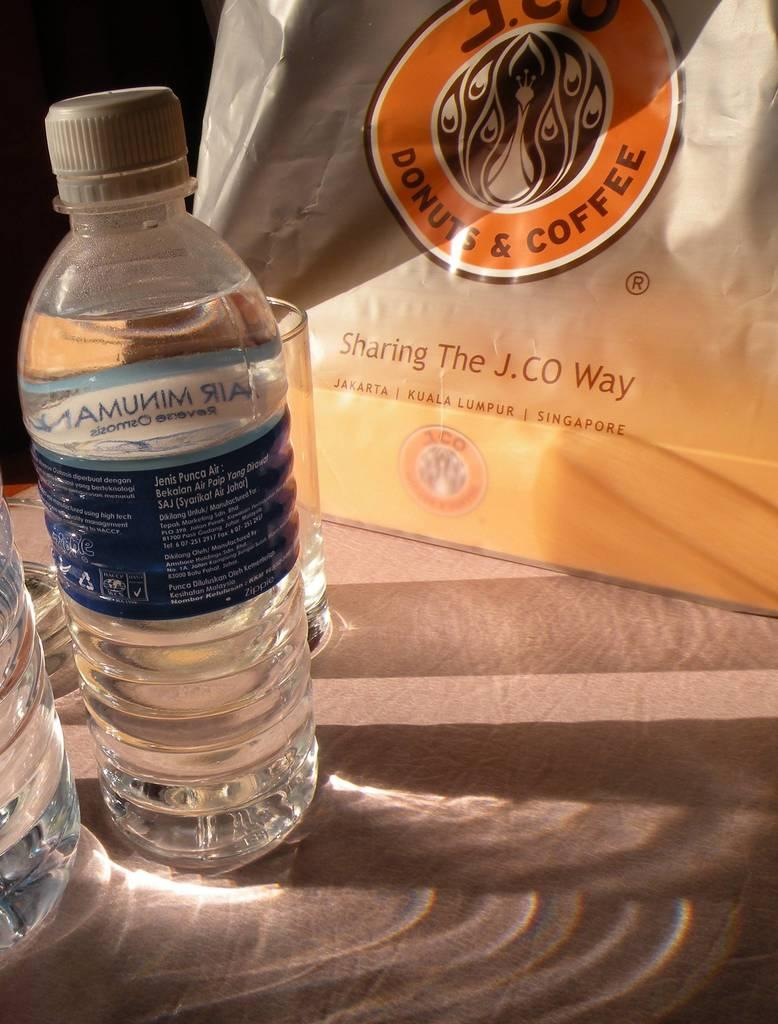Provide a one-sentence caption for the provided image. Two water bottles and a glass are next to a Donuts & Coffee bag. 